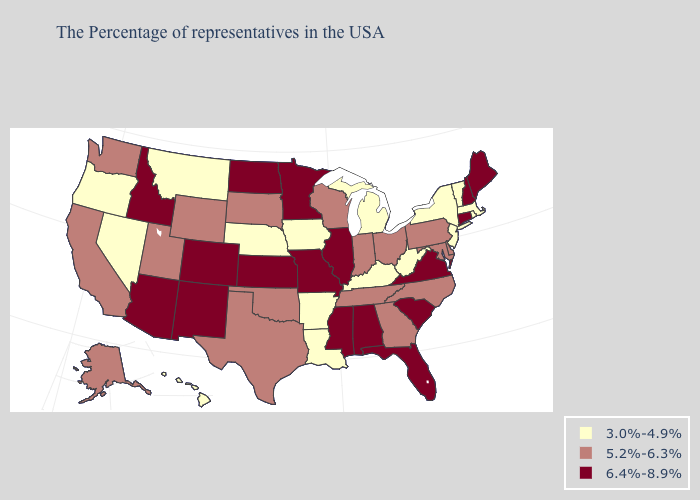Among the states that border Nebraska , does Missouri have the highest value?
Write a very short answer. Yes. What is the lowest value in states that border Colorado?
Short answer required. 3.0%-4.9%. Among the states that border California , does Oregon have the lowest value?
Write a very short answer. Yes. Among the states that border Kansas , does Oklahoma have the highest value?
Give a very brief answer. No. Among the states that border New Hampshire , does Maine have the lowest value?
Keep it brief. No. What is the value of Virginia?
Quick response, please. 6.4%-8.9%. Name the states that have a value in the range 3.0%-4.9%?
Keep it brief. Massachusetts, Rhode Island, Vermont, New York, New Jersey, West Virginia, Michigan, Kentucky, Louisiana, Arkansas, Iowa, Nebraska, Montana, Nevada, Oregon, Hawaii. Is the legend a continuous bar?
Concise answer only. No. Does the first symbol in the legend represent the smallest category?
Be succinct. Yes. What is the highest value in the West ?
Give a very brief answer. 6.4%-8.9%. What is the value of West Virginia?
Short answer required. 3.0%-4.9%. What is the highest value in states that border Iowa?
Short answer required. 6.4%-8.9%. Name the states that have a value in the range 6.4%-8.9%?
Short answer required. Maine, New Hampshire, Connecticut, Virginia, South Carolina, Florida, Alabama, Illinois, Mississippi, Missouri, Minnesota, Kansas, North Dakota, Colorado, New Mexico, Arizona, Idaho. Does Maryland have a higher value than Oregon?
Concise answer only. Yes. 